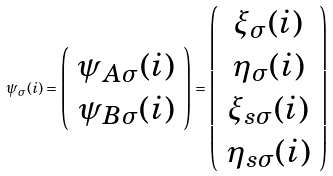Convert formula to latex. <formula><loc_0><loc_0><loc_500><loc_500>\psi _ { \sigma } ( i ) = \left ( \begin{array} { c } \psi _ { A \sigma } ( i ) \\ \psi _ { B \sigma } ( i ) \end{array} \right ) = \left ( \begin{array} { c } \xi _ { \sigma } ( i ) \\ \eta _ { \sigma } ( i ) \\ \xi _ { s \sigma } ( i ) \\ \eta _ { s \sigma } ( i ) \end{array} \right )</formula> 